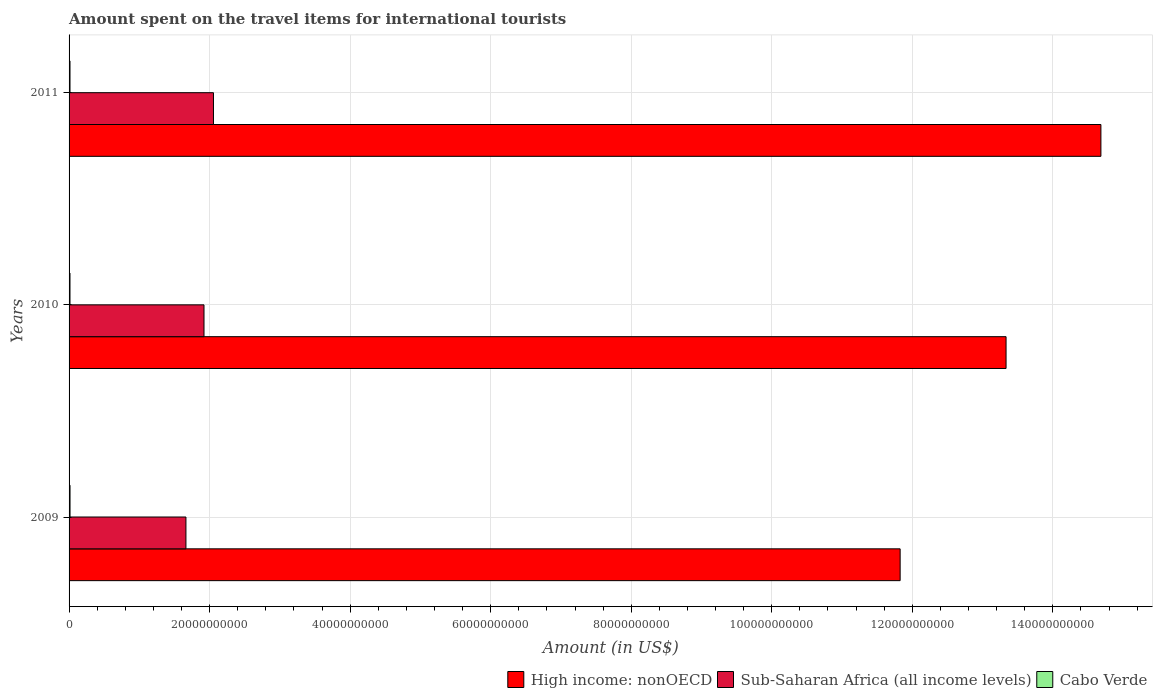How many different coloured bars are there?
Offer a terse response. 3. Are the number of bars per tick equal to the number of legend labels?
Give a very brief answer. Yes. Are the number of bars on each tick of the Y-axis equal?
Your response must be concise. Yes. How many bars are there on the 1st tick from the top?
Your answer should be compact. 3. What is the label of the 1st group of bars from the top?
Your answer should be compact. 2011. In how many cases, is the number of bars for a given year not equal to the number of legend labels?
Your response must be concise. 0. What is the amount spent on the travel items for international tourists in Cabo Verde in 2010?
Offer a very short reply. 1.29e+08. Across all years, what is the maximum amount spent on the travel items for international tourists in Cabo Verde?
Provide a succinct answer. 1.36e+08. Across all years, what is the minimum amount spent on the travel items for international tourists in High income: nonOECD?
Provide a short and direct response. 1.18e+11. In which year was the amount spent on the travel items for international tourists in Sub-Saharan Africa (all income levels) maximum?
Your answer should be compact. 2011. In which year was the amount spent on the travel items for international tourists in Sub-Saharan Africa (all income levels) minimum?
Your answer should be compact. 2009. What is the total amount spent on the travel items for international tourists in Cabo Verde in the graph?
Provide a short and direct response. 3.97e+08. What is the difference between the amount spent on the travel items for international tourists in Sub-Saharan Africa (all income levels) in 2009 and that in 2010?
Make the answer very short. -2.57e+09. What is the difference between the amount spent on the travel items for international tourists in High income: nonOECD in 2010 and the amount spent on the travel items for international tourists in Sub-Saharan Africa (all income levels) in 2009?
Your response must be concise. 1.17e+11. What is the average amount spent on the travel items for international tourists in Cabo Verde per year?
Provide a short and direct response. 1.32e+08. In the year 2010, what is the difference between the amount spent on the travel items for international tourists in Sub-Saharan Africa (all income levels) and amount spent on the travel items for international tourists in Cabo Verde?
Your answer should be compact. 1.91e+1. In how many years, is the amount spent on the travel items for international tourists in Cabo Verde greater than 4000000000 US$?
Provide a succinct answer. 0. What is the ratio of the amount spent on the travel items for international tourists in High income: nonOECD in 2009 to that in 2010?
Provide a succinct answer. 0.89. What is the difference between the highest and the second highest amount spent on the travel items for international tourists in High income: nonOECD?
Provide a short and direct response. 1.35e+1. What is the difference between the highest and the lowest amount spent on the travel items for international tourists in High income: nonOECD?
Offer a very short reply. 2.86e+1. What does the 3rd bar from the top in 2011 represents?
Your response must be concise. High income: nonOECD. What does the 3rd bar from the bottom in 2009 represents?
Provide a short and direct response. Cabo Verde. Is it the case that in every year, the sum of the amount spent on the travel items for international tourists in High income: nonOECD and amount spent on the travel items for international tourists in Sub-Saharan Africa (all income levels) is greater than the amount spent on the travel items for international tourists in Cabo Verde?
Provide a succinct answer. Yes. How many bars are there?
Make the answer very short. 9. How many years are there in the graph?
Offer a very short reply. 3. Does the graph contain any zero values?
Your response must be concise. No. Where does the legend appear in the graph?
Offer a terse response. Bottom right. How many legend labels are there?
Provide a short and direct response. 3. What is the title of the graph?
Ensure brevity in your answer.  Amount spent on the travel items for international tourists. Does "Guyana" appear as one of the legend labels in the graph?
Your answer should be very brief. No. What is the label or title of the X-axis?
Ensure brevity in your answer.  Amount (in US$). What is the label or title of the Y-axis?
Keep it short and to the point. Years. What is the Amount (in US$) of High income: nonOECD in 2009?
Provide a succinct answer. 1.18e+11. What is the Amount (in US$) in Sub-Saharan Africa (all income levels) in 2009?
Offer a very short reply. 1.66e+1. What is the Amount (in US$) in Cabo Verde in 2009?
Provide a succinct answer. 1.36e+08. What is the Amount (in US$) of High income: nonOECD in 2010?
Make the answer very short. 1.33e+11. What is the Amount (in US$) in Sub-Saharan Africa (all income levels) in 2010?
Keep it short and to the point. 1.92e+1. What is the Amount (in US$) of Cabo Verde in 2010?
Make the answer very short. 1.29e+08. What is the Amount (in US$) in High income: nonOECD in 2011?
Provide a succinct answer. 1.47e+11. What is the Amount (in US$) in Sub-Saharan Africa (all income levels) in 2011?
Provide a short and direct response. 2.06e+1. What is the Amount (in US$) of Cabo Verde in 2011?
Provide a short and direct response. 1.32e+08. Across all years, what is the maximum Amount (in US$) of High income: nonOECD?
Provide a succinct answer. 1.47e+11. Across all years, what is the maximum Amount (in US$) in Sub-Saharan Africa (all income levels)?
Give a very brief answer. 2.06e+1. Across all years, what is the maximum Amount (in US$) in Cabo Verde?
Make the answer very short. 1.36e+08. Across all years, what is the minimum Amount (in US$) of High income: nonOECD?
Offer a very short reply. 1.18e+11. Across all years, what is the minimum Amount (in US$) in Sub-Saharan Africa (all income levels)?
Give a very brief answer. 1.66e+1. Across all years, what is the minimum Amount (in US$) of Cabo Verde?
Keep it short and to the point. 1.29e+08. What is the total Amount (in US$) of High income: nonOECD in the graph?
Keep it short and to the point. 3.98e+11. What is the total Amount (in US$) in Sub-Saharan Africa (all income levels) in the graph?
Offer a terse response. 5.64e+1. What is the total Amount (in US$) of Cabo Verde in the graph?
Your answer should be compact. 3.97e+08. What is the difference between the Amount (in US$) of High income: nonOECD in 2009 and that in 2010?
Ensure brevity in your answer.  -1.51e+1. What is the difference between the Amount (in US$) in Sub-Saharan Africa (all income levels) in 2009 and that in 2010?
Your answer should be compact. -2.57e+09. What is the difference between the Amount (in US$) in High income: nonOECD in 2009 and that in 2011?
Make the answer very short. -2.86e+1. What is the difference between the Amount (in US$) of Sub-Saharan Africa (all income levels) in 2009 and that in 2011?
Keep it short and to the point. -3.92e+09. What is the difference between the Amount (in US$) of High income: nonOECD in 2010 and that in 2011?
Provide a succinct answer. -1.35e+1. What is the difference between the Amount (in US$) of Sub-Saharan Africa (all income levels) in 2010 and that in 2011?
Ensure brevity in your answer.  -1.35e+09. What is the difference between the Amount (in US$) in Cabo Verde in 2010 and that in 2011?
Make the answer very short. -3.00e+06. What is the difference between the Amount (in US$) of High income: nonOECD in 2009 and the Amount (in US$) of Sub-Saharan Africa (all income levels) in 2010?
Offer a terse response. 9.91e+1. What is the difference between the Amount (in US$) in High income: nonOECD in 2009 and the Amount (in US$) in Cabo Verde in 2010?
Offer a very short reply. 1.18e+11. What is the difference between the Amount (in US$) of Sub-Saharan Africa (all income levels) in 2009 and the Amount (in US$) of Cabo Verde in 2010?
Offer a very short reply. 1.65e+1. What is the difference between the Amount (in US$) of High income: nonOECD in 2009 and the Amount (in US$) of Sub-Saharan Africa (all income levels) in 2011?
Your response must be concise. 9.77e+1. What is the difference between the Amount (in US$) of High income: nonOECD in 2009 and the Amount (in US$) of Cabo Verde in 2011?
Provide a succinct answer. 1.18e+11. What is the difference between the Amount (in US$) in Sub-Saharan Africa (all income levels) in 2009 and the Amount (in US$) in Cabo Verde in 2011?
Ensure brevity in your answer.  1.65e+1. What is the difference between the Amount (in US$) of High income: nonOECD in 2010 and the Amount (in US$) of Sub-Saharan Africa (all income levels) in 2011?
Offer a very short reply. 1.13e+11. What is the difference between the Amount (in US$) of High income: nonOECD in 2010 and the Amount (in US$) of Cabo Verde in 2011?
Offer a very short reply. 1.33e+11. What is the difference between the Amount (in US$) of Sub-Saharan Africa (all income levels) in 2010 and the Amount (in US$) of Cabo Verde in 2011?
Offer a very short reply. 1.91e+1. What is the average Amount (in US$) of High income: nonOECD per year?
Provide a short and direct response. 1.33e+11. What is the average Amount (in US$) in Sub-Saharan Africa (all income levels) per year?
Offer a terse response. 1.88e+1. What is the average Amount (in US$) in Cabo Verde per year?
Your response must be concise. 1.32e+08. In the year 2009, what is the difference between the Amount (in US$) of High income: nonOECD and Amount (in US$) of Sub-Saharan Africa (all income levels)?
Make the answer very short. 1.02e+11. In the year 2009, what is the difference between the Amount (in US$) in High income: nonOECD and Amount (in US$) in Cabo Verde?
Give a very brief answer. 1.18e+11. In the year 2009, what is the difference between the Amount (in US$) of Sub-Saharan Africa (all income levels) and Amount (in US$) of Cabo Verde?
Your response must be concise. 1.65e+1. In the year 2010, what is the difference between the Amount (in US$) in High income: nonOECD and Amount (in US$) in Sub-Saharan Africa (all income levels)?
Make the answer very short. 1.14e+11. In the year 2010, what is the difference between the Amount (in US$) of High income: nonOECD and Amount (in US$) of Cabo Verde?
Keep it short and to the point. 1.33e+11. In the year 2010, what is the difference between the Amount (in US$) in Sub-Saharan Africa (all income levels) and Amount (in US$) in Cabo Verde?
Your answer should be compact. 1.91e+1. In the year 2011, what is the difference between the Amount (in US$) in High income: nonOECD and Amount (in US$) in Sub-Saharan Africa (all income levels)?
Your answer should be very brief. 1.26e+11. In the year 2011, what is the difference between the Amount (in US$) in High income: nonOECD and Amount (in US$) in Cabo Verde?
Provide a succinct answer. 1.47e+11. In the year 2011, what is the difference between the Amount (in US$) of Sub-Saharan Africa (all income levels) and Amount (in US$) of Cabo Verde?
Your answer should be compact. 2.04e+1. What is the ratio of the Amount (in US$) of High income: nonOECD in 2009 to that in 2010?
Your response must be concise. 0.89. What is the ratio of the Amount (in US$) in Sub-Saharan Africa (all income levels) in 2009 to that in 2010?
Offer a very short reply. 0.87. What is the ratio of the Amount (in US$) of Cabo Verde in 2009 to that in 2010?
Keep it short and to the point. 1.05. What is the ratio of the Amount (in US$) in High income: nonOECD in 2009 to that in 2011?
Your response must be concise. 0.81. What is the ratio of the Amount (in US$) of Sub-Saharan Africa (all income levels) in 2009 to that in 2011?
Give a very brief answer. 0.81. What is the ratio of the Amount (in US$) in Cabo Verde in 2009 to that in 2011?
Offer a terse response. 1.03. What is the ratio of the Amount (in US$) in High income: nonOECD in 2010 to that in 2011?
Provide a short and direct response. 0.91. What is the ratio of the Amount (in US$) of Sub-Saharan Africa (all income levels) in 2010 to that in 2011?
Provide a short and direct response. 0.93. What is the ratio of the Amount (in US$) of Cabo Verde in 2010 to that in 2011?
Your answer should be compact. 0.98. What is the difference between the highest and the second highest Amount (in US$) in High income: nonOECD?
Give a very brief answer. 1.35e+1. What is the difference between the highest and the second highest Amount (in US$) in Sub-Saharan Africa (all income levels)?
Offer a terse response. 1.35e+09. What is the difference between the highest and the second highest Amount (in US$) in Cabo Verde?
Provide a succinct answer. 4.00e+06. What is the difference between the highest and the lowest Amount (in US$) in High income: nonOECD?
Make the answer very short. 2.86e+1. What is the difference between the highest and the lowest Amount (in US$) in Sub-Saharan Africa (all income levels)?
Ensure brevity in your answer.  3.92e+09. 